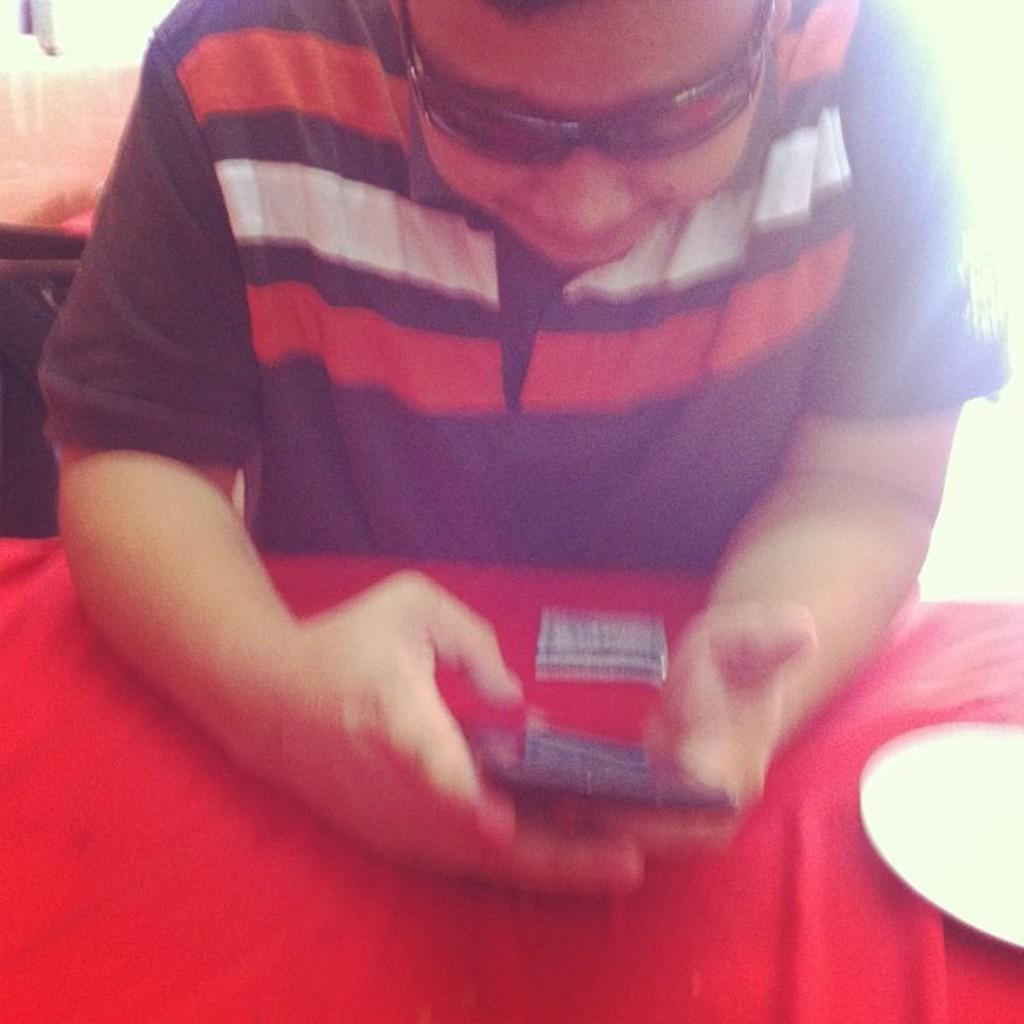What is the person in the image doing? The person is sitting in the image. What object is the person holding? The person is holding a mobile. What is in front of the person? There is a table in front of the person. What is on the table? There is a red cloth and a plate on the table. How many pies are on the table in the image? There is no mention of pies in the image; only a red cloth and a plate are present on the table. 